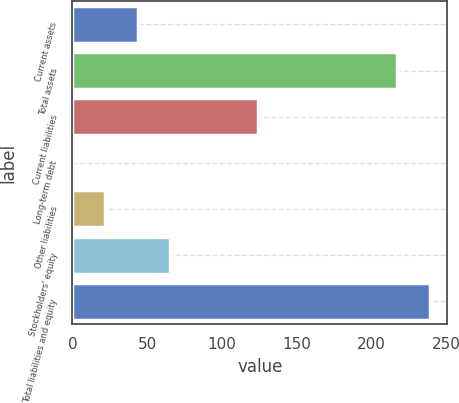<chart> <loc_0><loc_0><loc_500><loc_500><bar_chart><fcel>Current assets<fcel>Total assets<fcel>Current liabilities<fcel>Long-term debt<fcel>Other liabilities<fcel>Stockholders' equity<fcel>Total liabilities and equity<nl><fcel>43.8<fcel>217.4<fcel>124<fcel>0.4<fcel>22.1<fcel>65.5<fcel>239.1<nl></chart> 